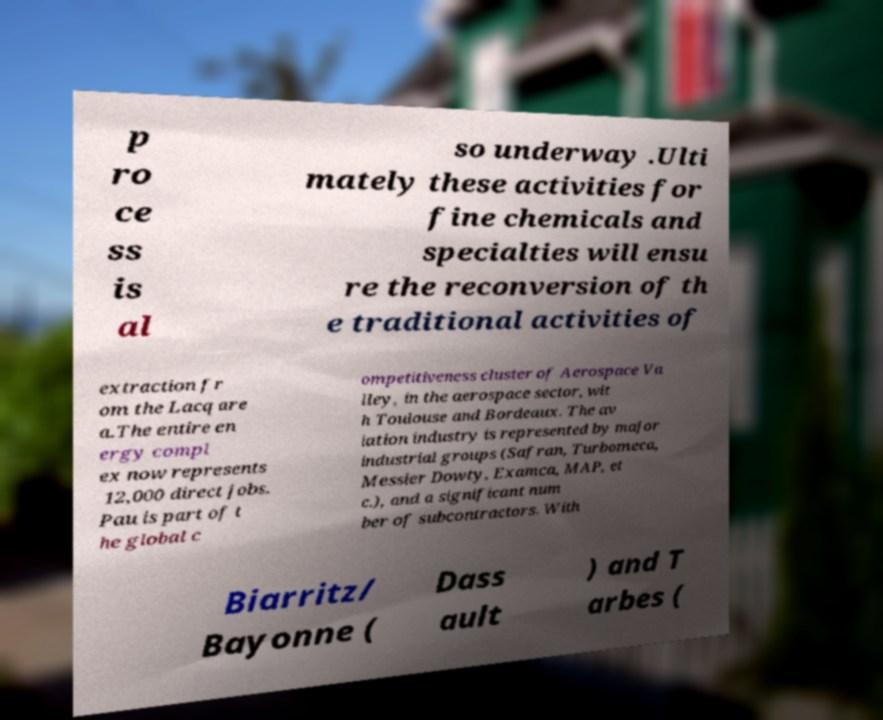Could you extract and type out the text from this image? p ro ce ss is al so underway .Ulti mately these activities for fine chemicals and specialties will ensu re the reconversion of th e traditional activities of extraction fr om the Lacq are a.The entire en ergy compl ex now represents 12,000 direct jobs. Pau is part of t he global c ompetitiveness cluster of Aerospace Va lley, in the aerospace sector, wit h Toulouse and Bordeaux. The av iation industry is represented by major industrial groups (Safran, Turbomeca, Messier Dowty, Examca, MAP, et c.), and a significant num ber of subcontractors. With Biarritz/ Bayonne ( Dass ault ) and T arbes ( 